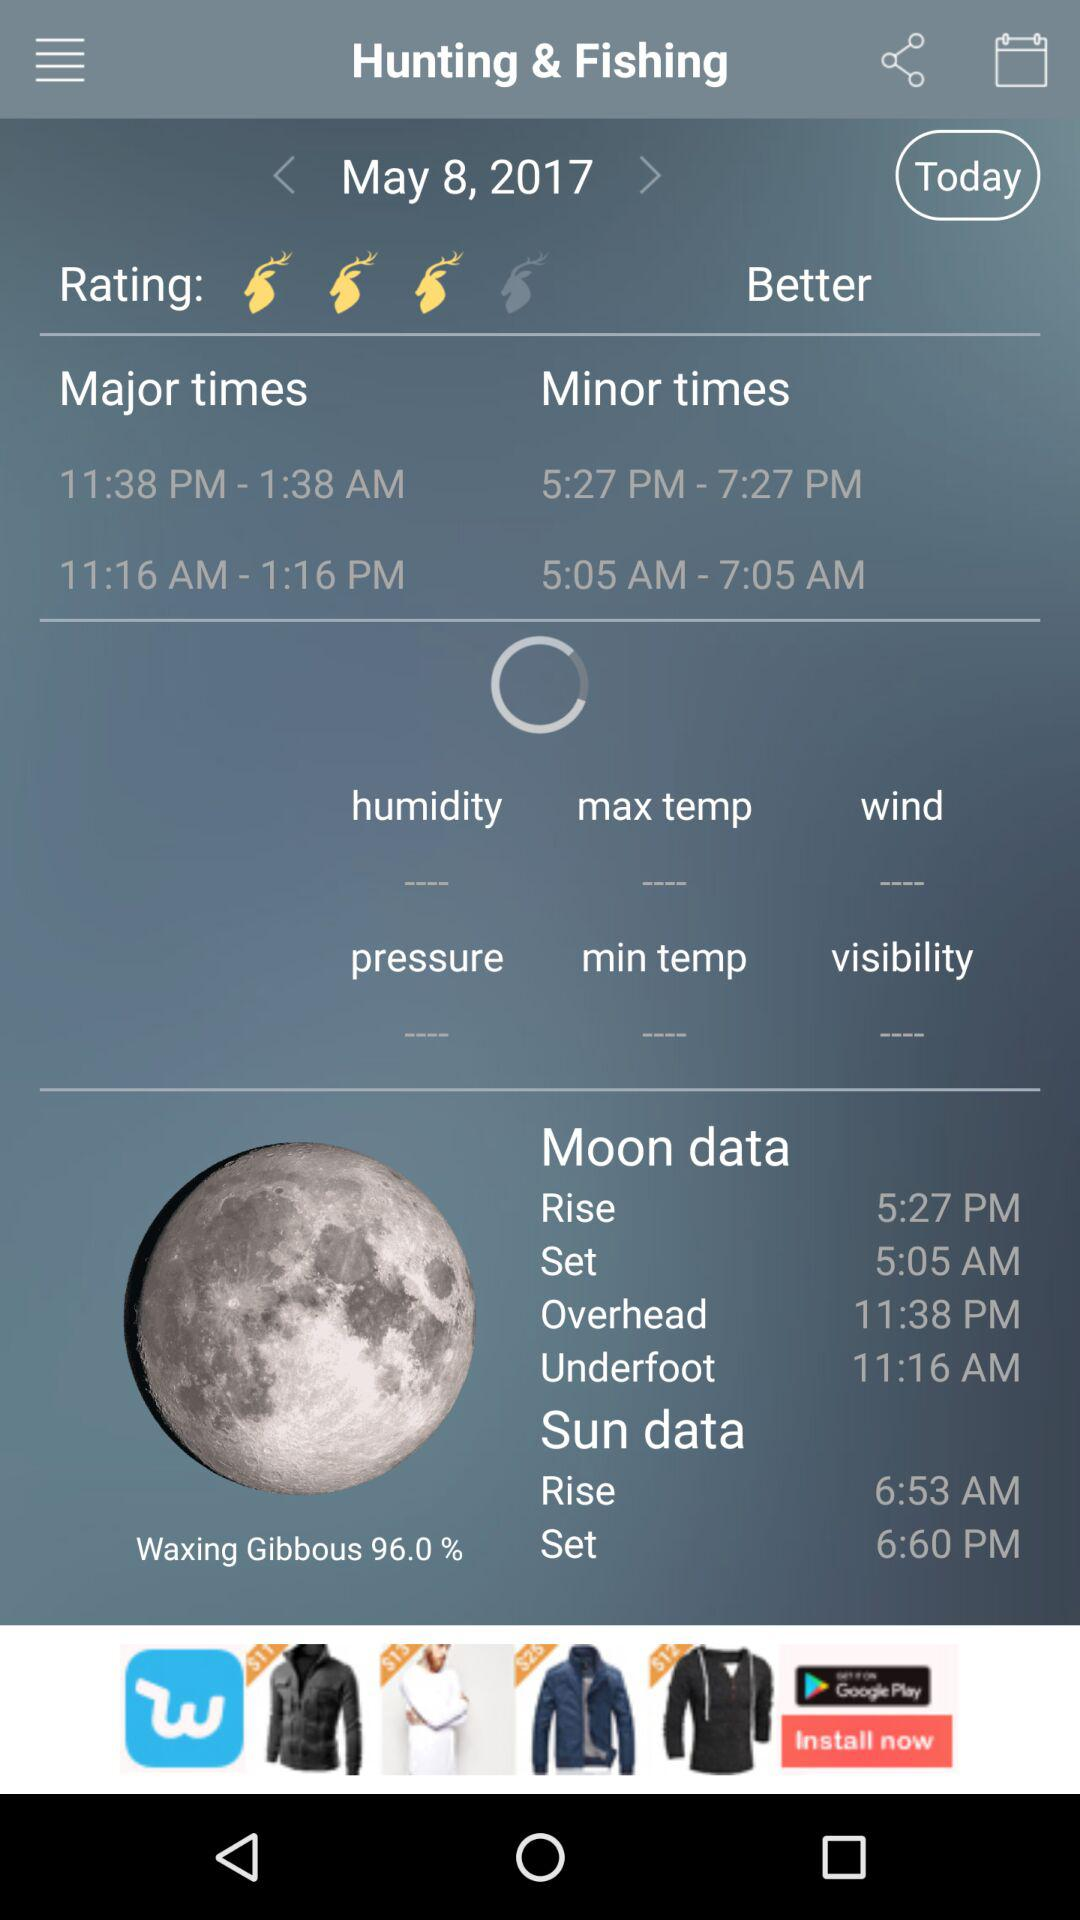At what time is the moon overhead? The moon's overhead time is 11:38 PM. 